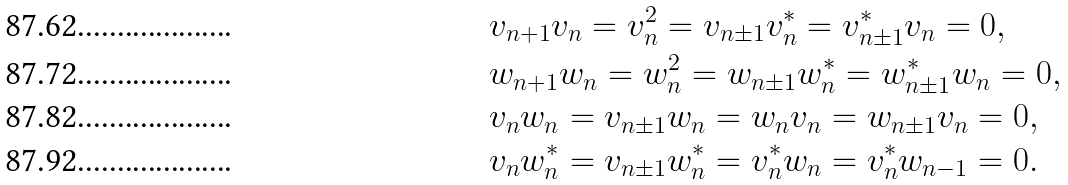Convert formula to latex. <formula><loc_0><loc_0><loc_500><loc_500>& v _ { n + 1 } v _ { n } = v _ { n } ^ { 2 } = v _ { n \pm 1 } v _ { n } ^ { * } = v _ { n \pm 1 } ^ { * } v _ { n } = 0 , \\ & w _ { n + 1 } w _ { n } = w _ { n } ^ { 2 } = w _ { n \pm 1 } w _ { n } ^ { * } = w _ { n \pm 1 } ^ { * } w _ { n } = 0 , \\ & v _ { n } w _ { n } = v _ { n \pm 1 } w _ { n } = w _ { n } v _ { n } = w _ { n \pm 1 } v _ { n } = 0 , \\ & v _ { n } w _ { n } ^ { * } = v _ { n \pm 1 } w _ { n } ^ { * } = v _ { n } ^ { * } w _ { n } = v _ { n } ^ { * } w _ { n - 1 } = 0 .</formula> 